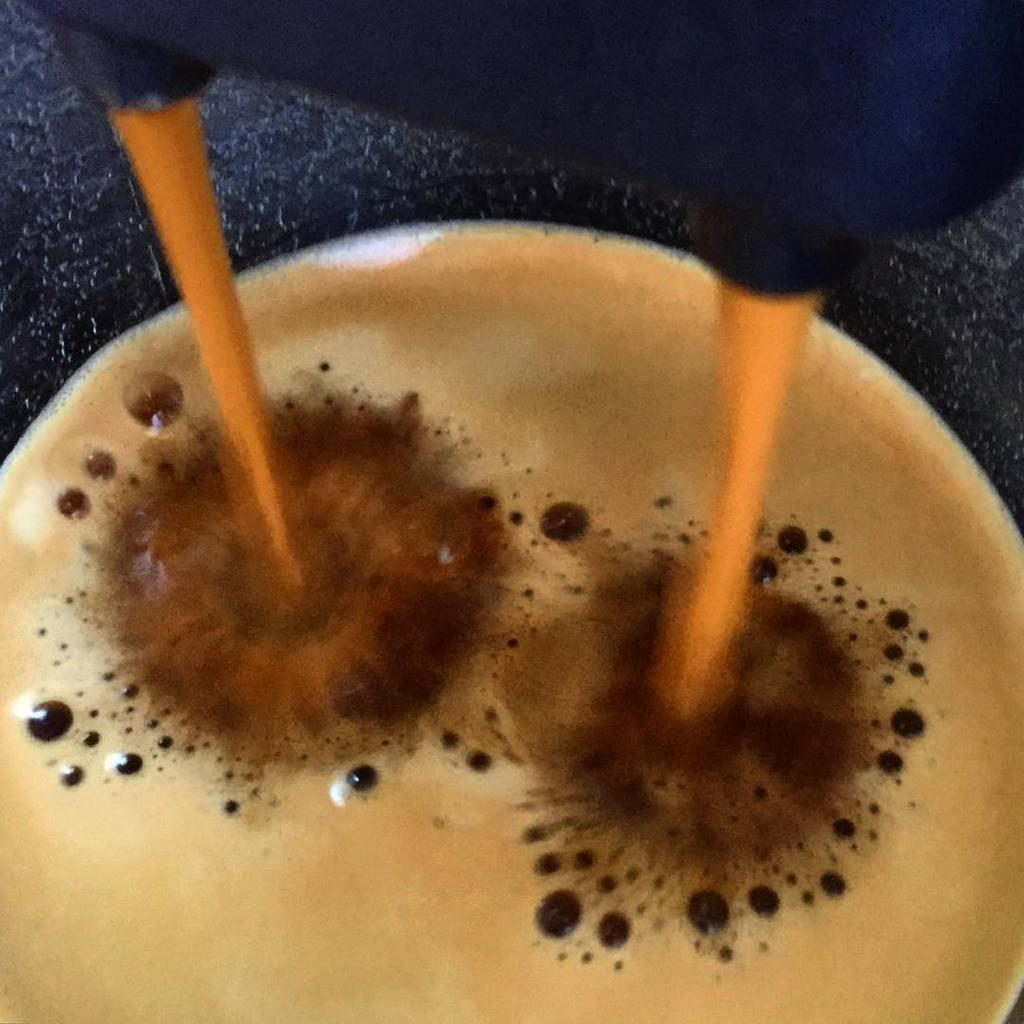What type of appliance is visible in the image? There is a coffee machine in the image. What might be used to hold coffee in the image? There is a coffee cup in the image. How many women are wearing a crown in the image? There are no women or crowns present in the image. 